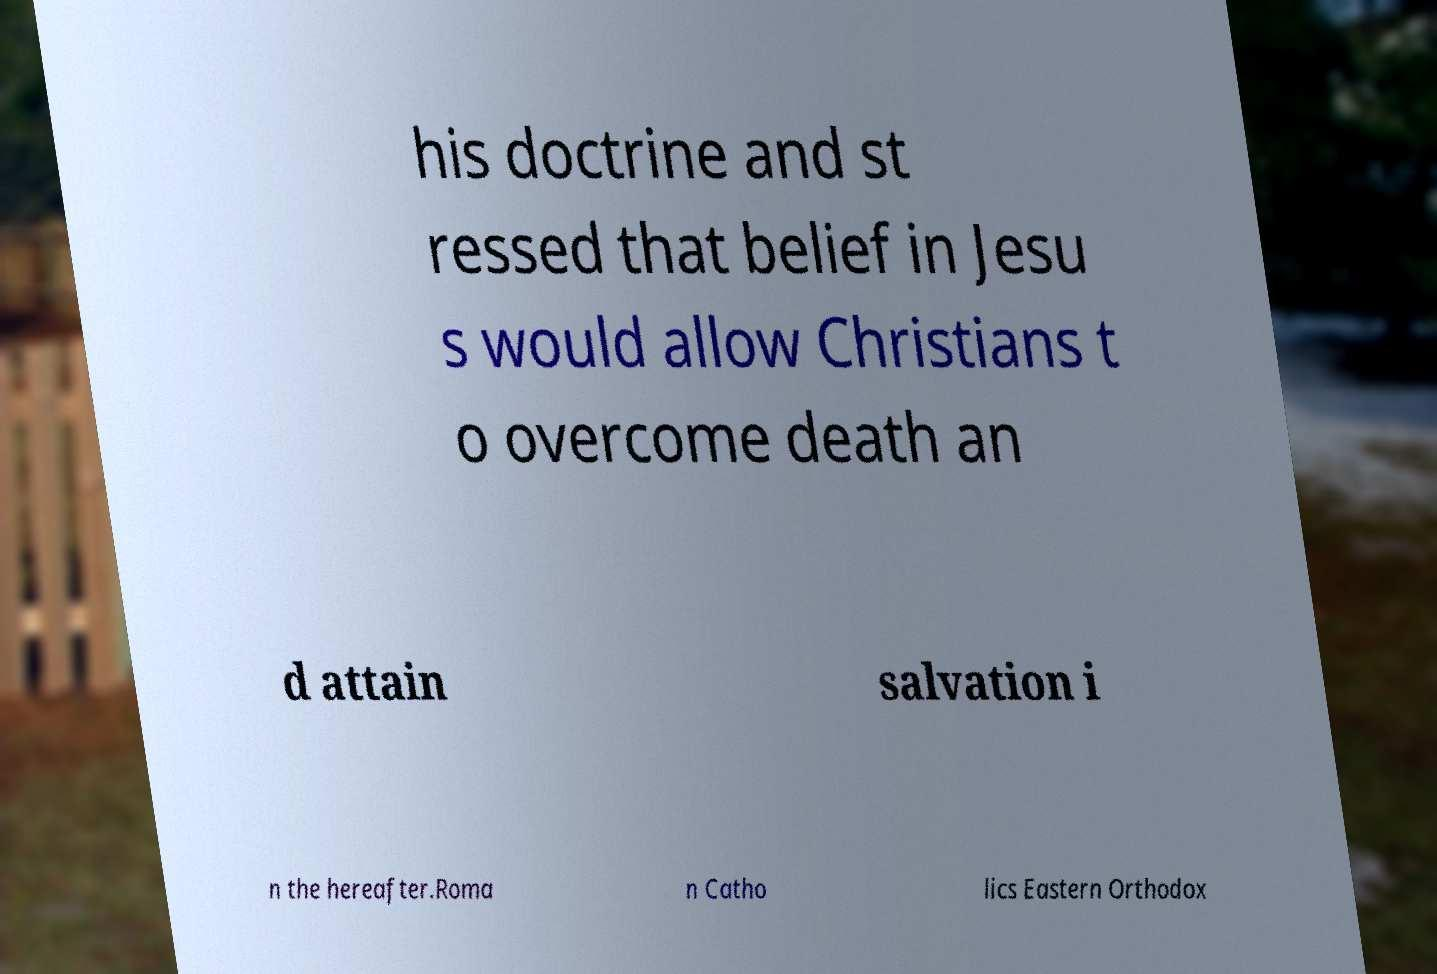Please read and relay the text visible in this image. What does it say? his doctrine and st ressed that belief in Jesu s would allow Christians t o overcome death an d attain salvation i n the hereafter.Roma n Catho lics Eastern Orthodox 